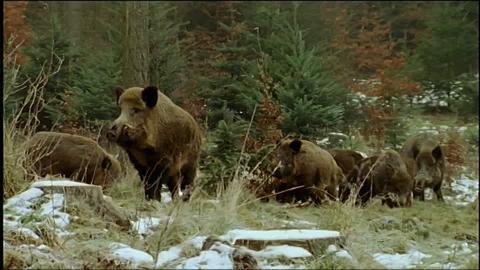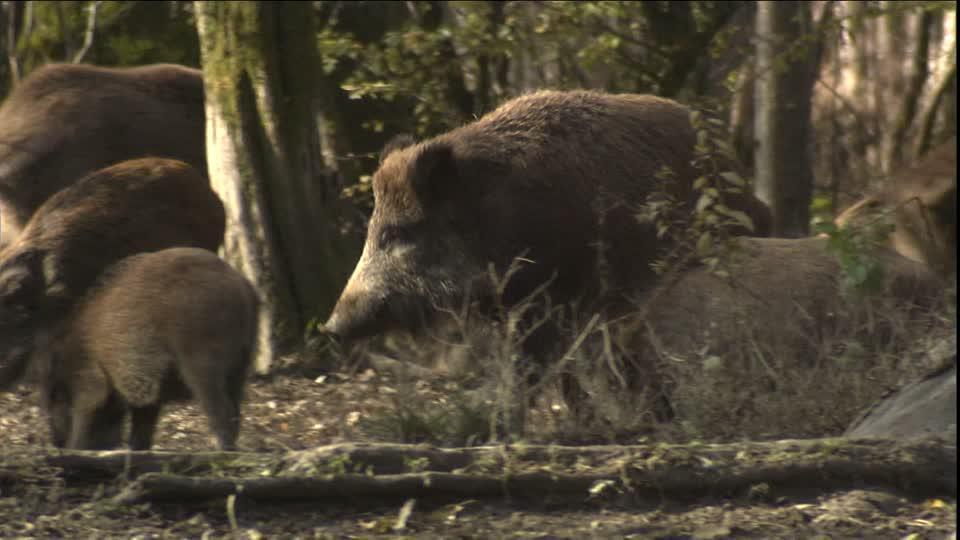The first image is the image on the left, the second image is the image on the right. Assess this claim about the two images: "Contains one picture with three or less pigs.". Correct or not? Answer yes or no. No. The first image is the image on the left, the second image is the image on the right. Considering the images on both sides, is "There are multiple wild boars in the center of both images." valid? Answer yes or no. Yes. 